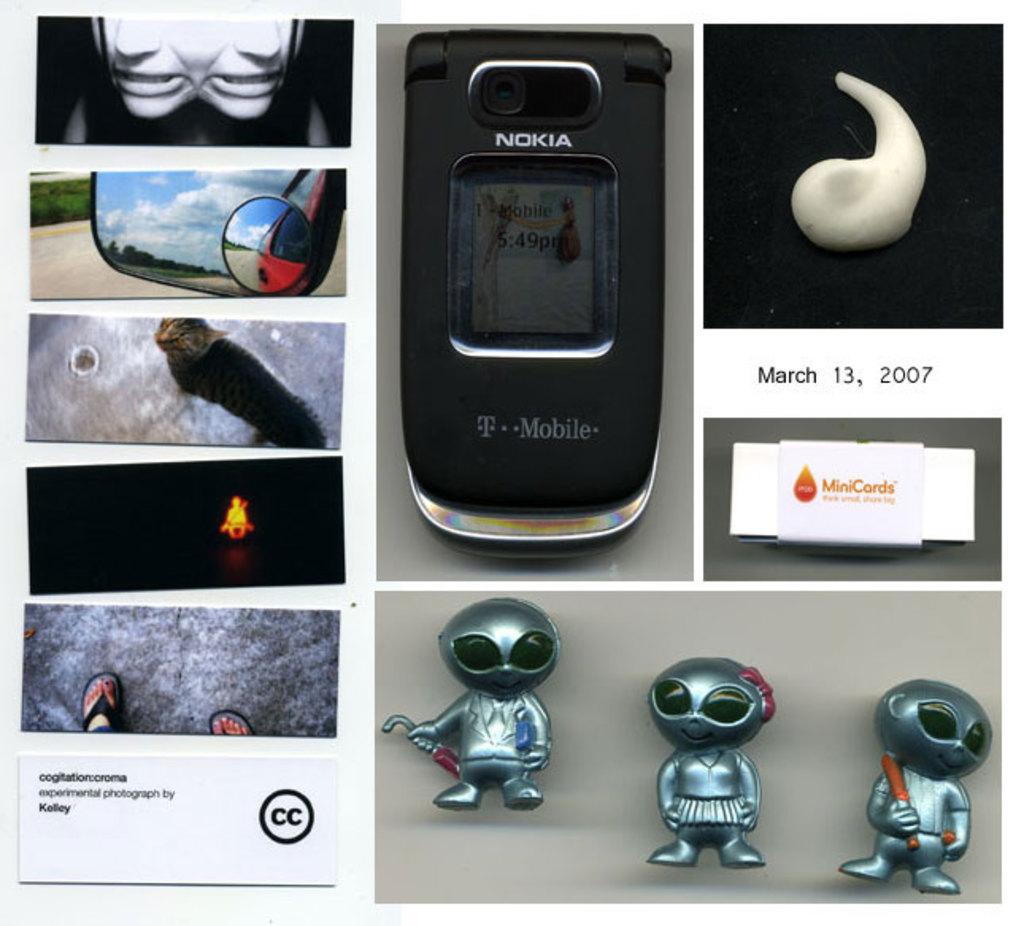What brand of phone is shown in the middle?
Keep it short and to the point. Nokia. What year is listed?
Offer a terse response. 2007. 